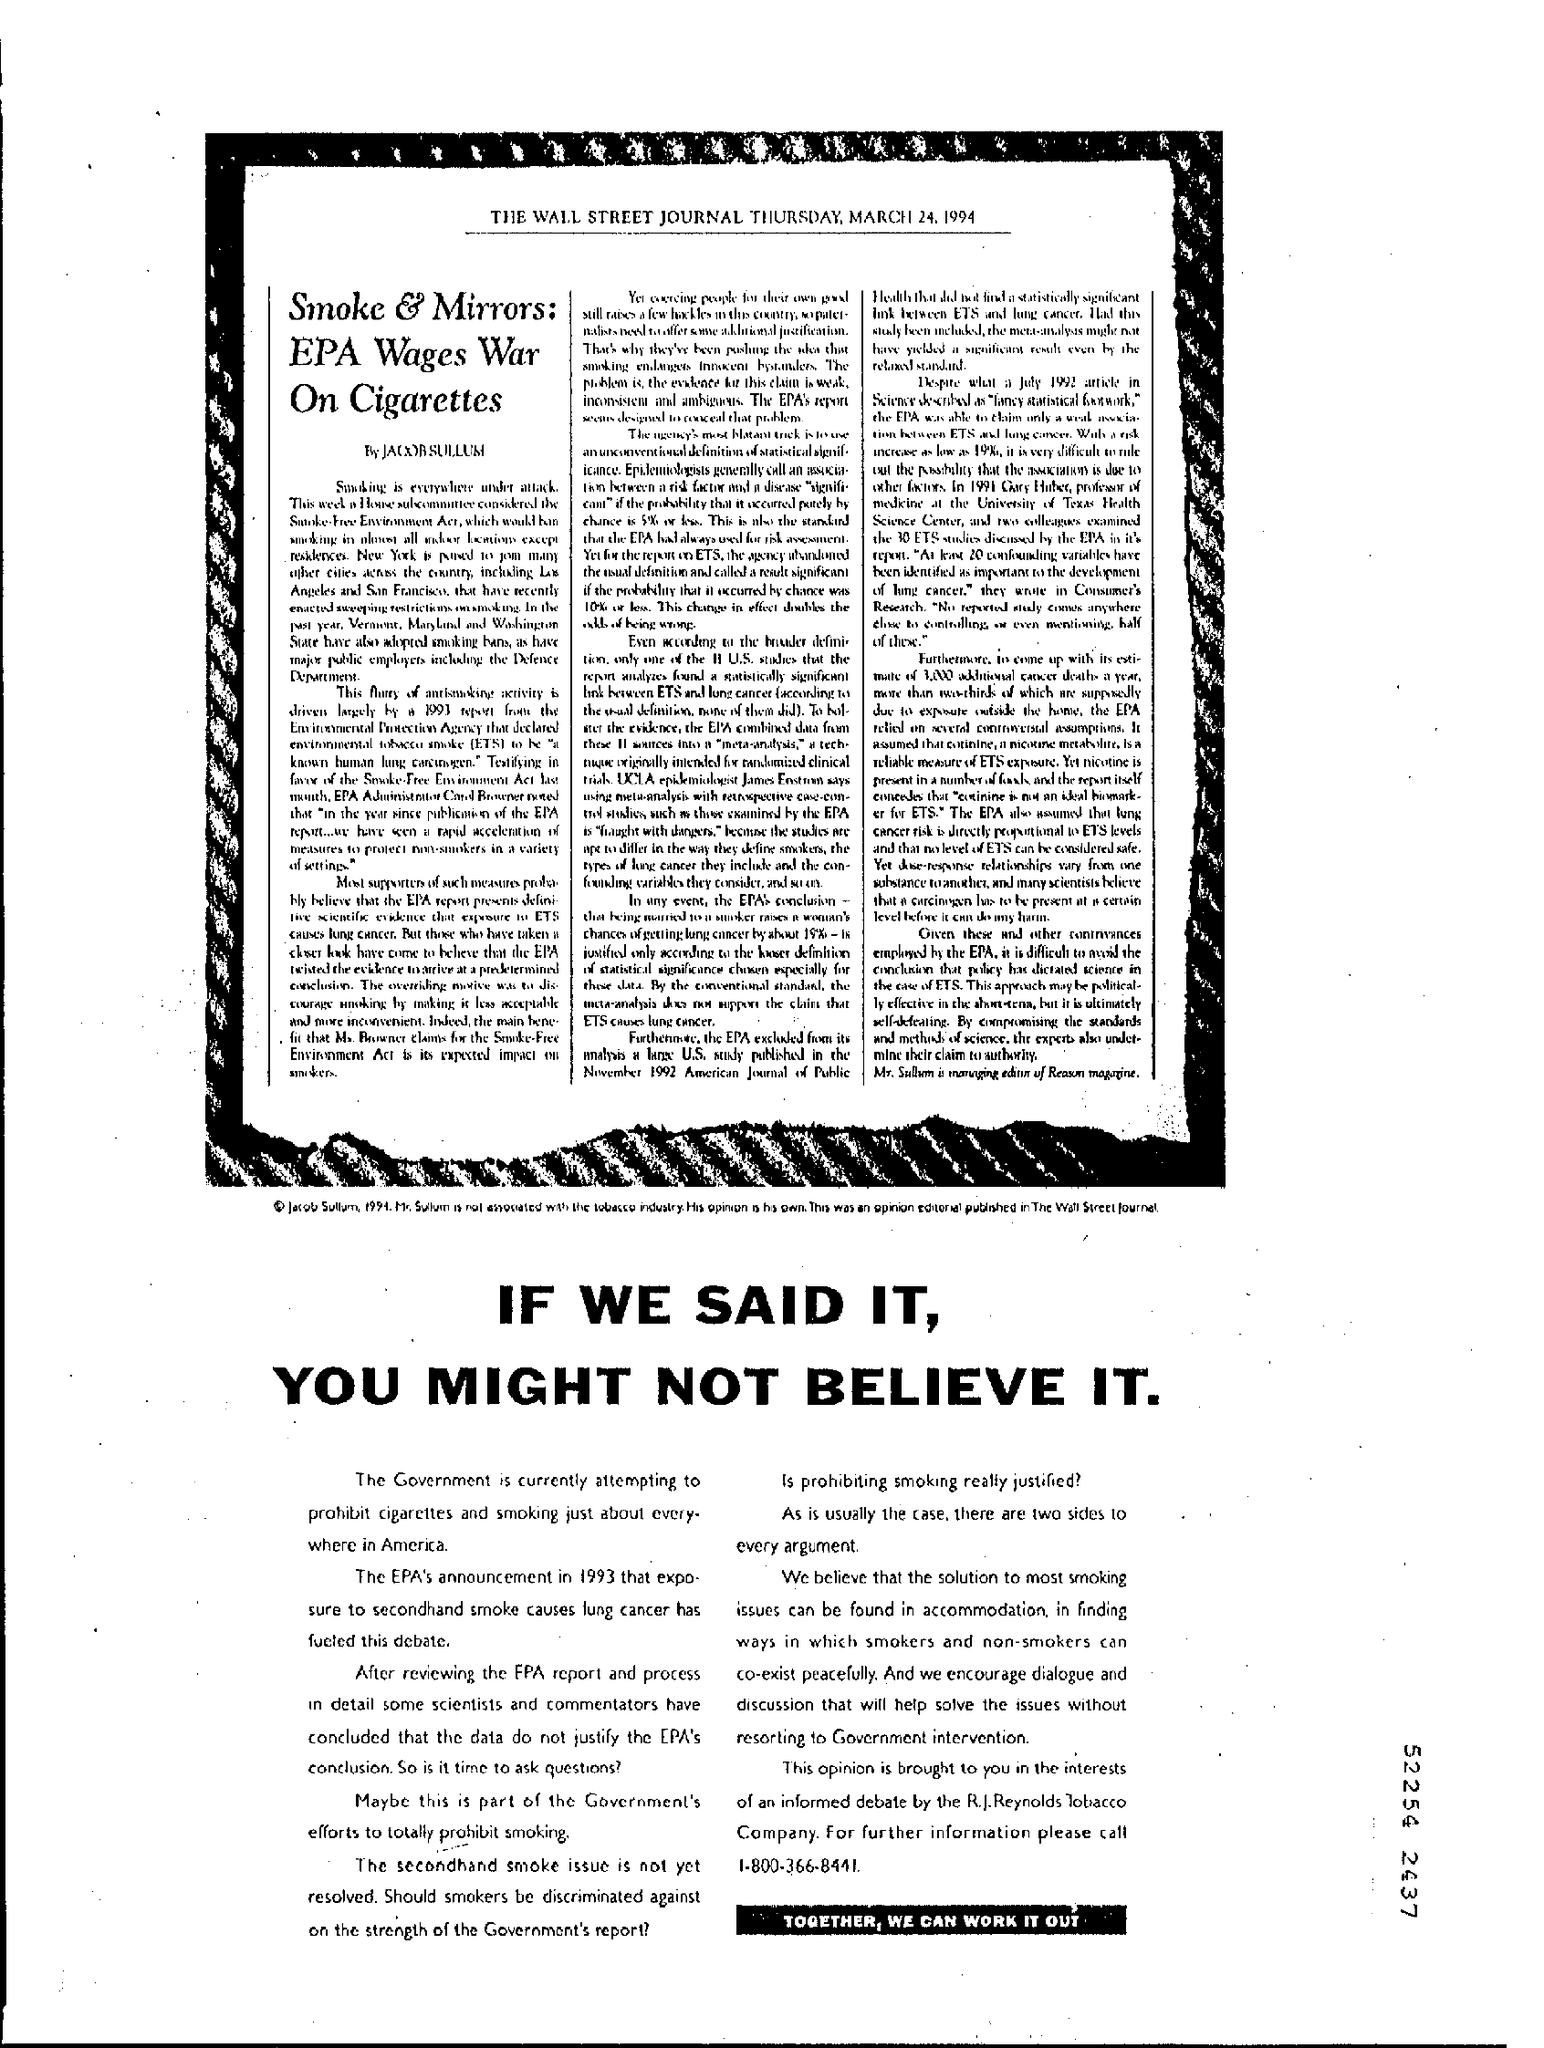Indicate a few pertinent items in this graphic. The article is titled "Smoke & Mirrors: EPA Wages War On Cigarettes," which reports on the Environmental Protection Agency's efforts to reduce the use of tobacco. The article was written by Jacob Sullum. The article is from the edition of the Wall Street Journal that was published on Thursday, March 24, 1994. 